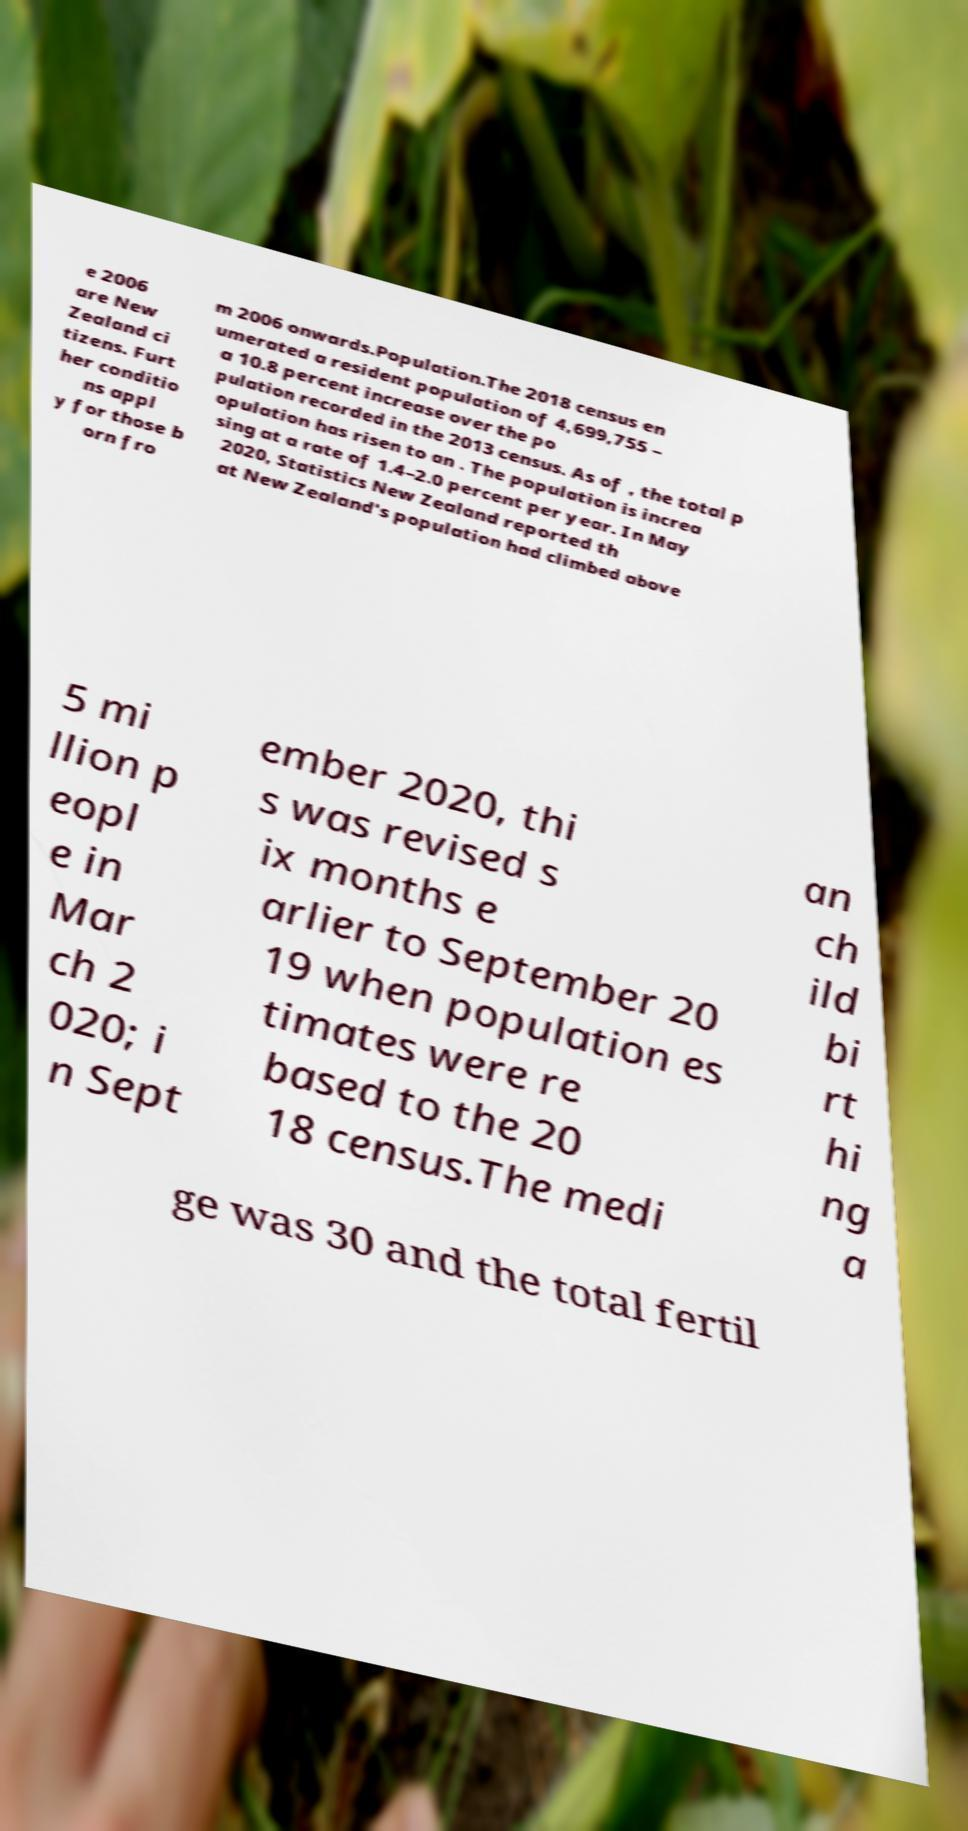For documentation purposes, I need the text within this image transcribed. Could you provide that? e 2006 are New Zealand ci tizens. Furt her conditio ns appl y for those b orn fro m 2006 onwards.Population.The 2018 census en umerated a resident population of 4,699,755 – a 10.8 percent increase over the po pulation recorded in the 2013 census. As of , the total p opulation has risen to an . The population is increa sing at a rate of 1.4–2.0 percent per year. In May 2020, Statistics New Zealand reported th at New Zealand's population had climbed above 5 mi llion p eopl e in Mar ch 2 020; i n Sept ember 2020, thi s was revised s ix months e arlier to September 20 19 when population es timates were re based to the 20 18 census.The medi an ch ild bi rt hi ng a ge was 30 and the total fertil 